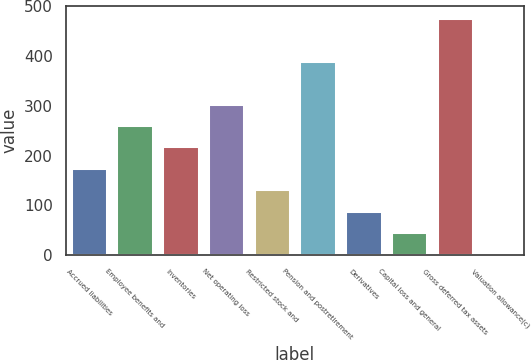Convert chart to OTSL. <chart><loc_0><loc_0><loc_500><loc_500><bar_chart><fcel>Accrued liabilities<fcel>Employee benefits and<fcel>Inventories<fcel>Net operating loss<fcel>Restricted stock and<fcel>Pension and postretirement<fcel>Derivatives<fcel>Capital loss and general<fcel>Gross deferred tax assets<fcel>Valuation allowance(c)<nl><fcel>175.3<fcel>261.4<fcel>218.35<fcel>304.45<fcel>132.25<fcel>390.55<fcel>89.2<fcel>46.15<fcel>476.65<fcel>3.1<nl></chart> 